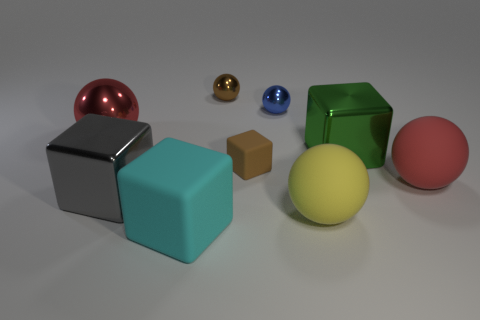There is a big object that is the same color as the large metal sphere; what material is it?
Your response must be concise. Rubber. What material is the blue thing?
Your response must be concise. Metal. Are there more metallic blocks that are in front of the blue metal object than large matte cylinders?
Provide a succinct answer. Yes. What number of yellow matte balls are behind the red sphere that is in front of the big sphere behind the red rubber object?
Provide a short and direct response. 0. What is the big thing that is both in front of the large gray metallic thing and behind the large cyan rubber block made of?
Give a very brief answer. Rubber. The tiny rubber block has what color?
Offer a terse response. Brown. Are there more large green objects that are in front of the brown rubber block than yellow spheres left of the large cyan matte thing?
Give a very brief answer. No. There is a rubber sphere in front of the big red rubber sphere; what color is it?
Offer a terse response. Yellow. Does the metal ball that is to the left of the cyan object have the same size as the matte cube that is behind the large gray block?
Your answer should be very brief. No. How many things are either blocks or tiny blue cylinders?
Give a very brief answer. 4. 